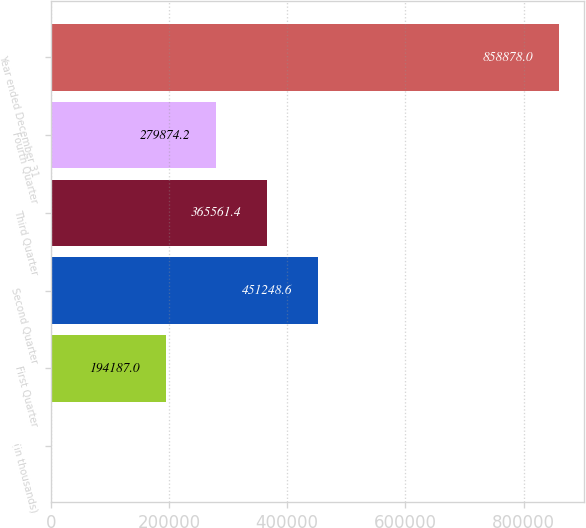Convert chart. <chart><loc_0><loc_0><loc_500><loc_500><bar_chart><fcel>(in thousands)<fcel>First Quarter<fcel>Second Quarter<fcel>Third Quarter<fcel>Fourth Quarter<fcel>Year ended December 31<nl><fcel>2006<fcel>194187<fcel>451249<fcel>365561<fcel>279874<fcel>858878<nl></chart> 